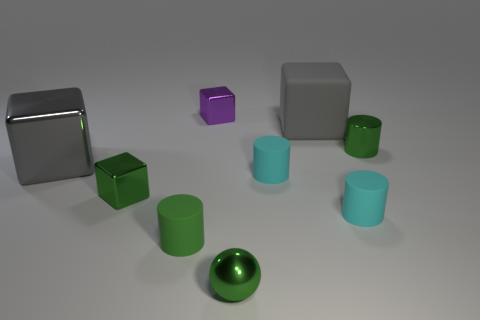Subtract all spheres. How many objects are left? 8 Add 6 small green metal blocks. How many small green metal blocks exist? 7 Subtract 0 gray balls. How many objects are left? 9 Subtract all purple rubber balls. Subtract all small purple metal objects. How many objects are left? 8 Add 7 small purple metallic blocks. How many small purple metallic blocks are left? 8 